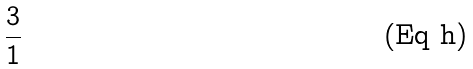Convert formula to latex. <formula><loc_0><loc_0><loc_500><loc_500>\frac { 3 } { 1 }</formula> 